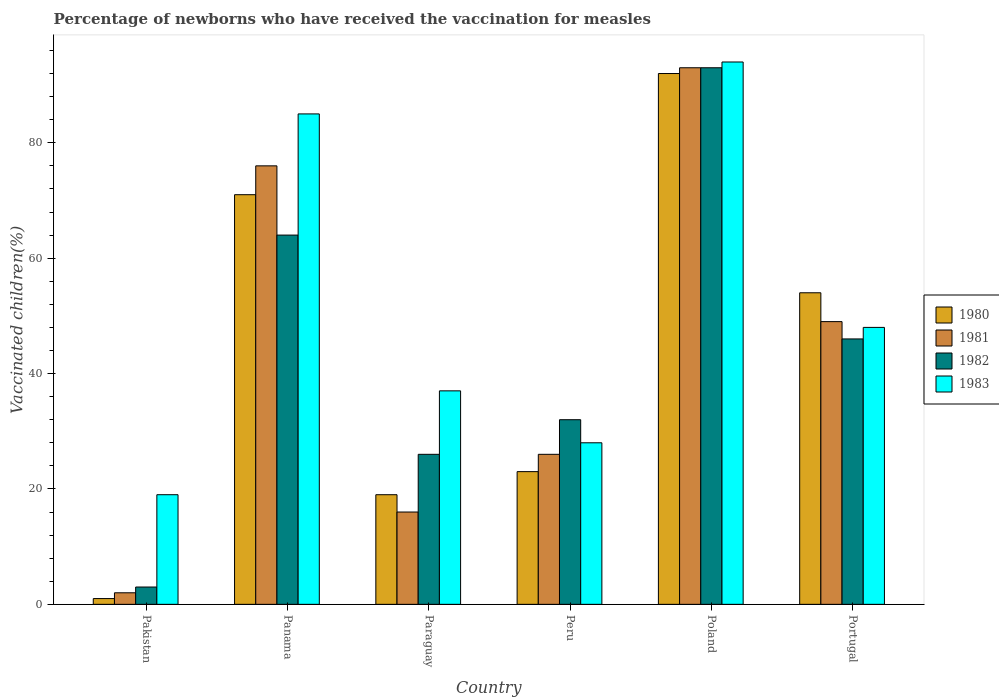How many groups of bars are there?
Your answer should be very brief. 6. How many bars are there on the 3rd tick from the right?
Make the answer very short. 4. In how many cases, is the number of bars for a given country not equal to the number of legend labels?
Offer a very short reply. 0. What is the percentage of vaccinated children in 1981 in Portugal?
Ensure brevity in your answer.  49. Across all countries, what is the maximum percentage of vaccinated children in 1980?
Offer a very short reply. 92. In which country was the percentage of vaccinated children in 1980 minimum?
Your answer should be very brief. Pakistan. What is the total percentage of vaccinated children in 1980 in the graph?
Keep it short and to the point. 260. What is the difference between the percentage of vaccinated children in 1983 in Peru and the percentage of vaccinated children in 1982 in Panama?
Provide a short and direct response. -36. What is the average percentage of vaccinated children in 1981 per country?
Keep it short and to the point. 43.67. What is the difference between the percentage of vaccinated children of/in 1982 and percentage of vaccinated children of/in 1980 in Paraguay?
Your answer should be compact. 7. What is the ratio of the percentage of vaccinated children in 1983 in Peru to that in Portugal?
Give a very brief answer. 0.58. Is the difference between the percentage of vaccinated children in 1982 in Pakistan and Paraguay greater than the difference between the percentage of vaccinated children in 1980 in Pakistan and Paraguay?
Your answer should be compact. No. What is the difference between the highest and the lowest percentage of vaccinated children in 1980?
Keep it short and to the point. 91. Is the sum of the percentage of vaccinated children in 1983 in Pakistan and Portugal greater than the maximum percentage of vaccinated children in 1981 across all countries?
Your response must be concise. No. Is it the case that in every country, the sum of the percentage of vaccinated children in 1981 and percentage of vaccinated children in 1980 is greater than the percentage of vaccinated children in 1982?
Your response must be concise. No. Are all the bars in the graph horizontal?
Offer a very short reply. No. Are the values on the major ticks of Y-axis written in scientific E-notation?
Give a very brief answer. No. Does the graph contain grids?
Provide a succinct answer. No. Where does the legend appear in the graph?
Provide a succinct answer. Center right. How many legend labels are there?
Your response must be concise. 4. What is the title of the graph?
Keep it short and to the point. Percentage of newborns who have received the vaccination for measles. What is the label or title of the X-axis?
Ensure brevity in your answer.  Country. What is the label or title of the Y-axis?
Give a very brief answer. Vaccinated children(%). What is the Vaccinated children(%) in 1980 in Pakistan?
Provide a short and direct response. 1. What is the Vaccinated children(%) of 1981 in Pakistan?
Give a very brief answer. 2. What is the Vaccinated children(%) in 1982 in Pakistan?
Provide a succinct answer. 3. What is the Vaccinated children(%) of 1983 in Pakistan?
Your answer should be compact. 19. What is the Vaccinated children(%) of 1980 in Panama?
Your response must be concise. 71. What is the Vaccinated children(%) of 1981 in Paraguay?
Give a very brief answer. 16. What is the Vaccinated children(%) in 1982 in Paraguay?
Ensure brevity in your answer.  26. What is the Vaccinated children(%) of 1980 in Poland?
Ensure brevity in your answer.  92. What is the Vaccinated children(%) in 1981 in Poland?
Make the answer very short. 93. What is the Vaccinated children(%) in 1982 in Poland?
Offer a terse response. 93. What is the Vaccinated children(%) in 1983 in Poland?
Keep it short and to the point. 94. What is the Vaccinated children(%) of 1982 in Portugal?
Provide a succinct answer. 46. What is the Vaccinated children(%) of 1983 in Portugal?
Provide a succinct answer. 48. Across all countries, what is the maximum Vaccinated children(%) of 1980?
Make the answer very short. 92. Across all countries, what is the maximum Vaccinated children(%) of 1981?
Provide a succinct answer. 93. Across all countries, what is the maximum Vaccinated children(%) in 1982?
Offer a very short reply. 93. Across all countries, what is the maximum Vaccinated children(%) in 1983?
Make the answer very short. 94. Across all countries, what is the minimum Vaccinated children(%) of 1980?
Your answer should be very brief. 1. Across all countries, what is the minimum Vaccinated children(%) in 1981?
Provide a succinct answer. 2. Across all countries, what is the minimum Vaccinated children(%) in 1982?
Offer a very short reply. 3. What is the total Vaccinated children(%) of 1980 in the graph?
Your response must be concise. 260. What is the total Vaccinated children(%) in 1981 in the graph?
Provide a succinct answer. 262. What is the total Vaccinated children(%) of 1982 in the graph?
Your answer should be very brief. 264. What is the total Vaccinated children(%) in 1983 in the graph?
Ensure brevity in your answer.  311. What is the difference between the Vaccinated children(%) of 1980 in Pakistan and that in Panama?
Give a very brief answer. -70. What is the difference between the Vaccinated children(%) in 1981 in Pakistan and that in Panama?
Your answer should be compact. -74. What is the difference between the Vaccinated children(%) of 1982 in Pakistan and that in Panama?
Your response must be concise. -61. What is the difference between the Vaccinated children(%) in 1983 in Pakistan and that in Panama?
Your response must be concise. -66. What is the difference between the Vaccinated children(%) of 1980 in Pakistan and that in Paraguay?
Provide a short and direct response. -18. What is the difference between the Vaccinated children(%) of 1983 in Pakistan and that in Paraguay?
Provide a short and direct response. -18. What is the difference between the Vaccinated children(%) in 1981 in Pakistan and that in Peru?
Offer a very short reply. -24. What is the difference between the Vaccinated children(%) of 1983 in Pakistan and that in Peru?
Give a very brief answer. -9. What is the difference between the Vaccinated children(%) of 1980 in Pakistan and that in Poland?
Offer a very short reply. -91. What is the difference between the Vaccinated children(%) of 1981 in Pakistan and that in Poland?
Ensure brevity in your answer.  -91. What is the difference between the Vaccinated children(%) of 1982 in Pakistan and that in Poland?
Your response must be concise. -90. What is the difference between the Vaccinated children(%) in 1983 in Pakistan and that in Poland?
Your answer should be compact. -75. What is the difference between the Vaccinated children(%) in 1980 in Pakistan and that in Portugal?
Provide a succinct answer. -53. What is the difference between the Vaccinated children(%) of 1981 in Pakistan and that in Portugal?
Provide a short and direct response. -47. What is the difference between the Vaccinated children(%) of 1982 in Pakistan and that in Portugal?
Ensure brevity in your answer.  -43. What is the difference between the Vaccinated children(%) of 1983 in Pakistan and that in Portugal?
Your answer should be compact. -29. What is the difference between the Vaccinated children(%) of 1980 in Panama and that in Paraguay?
Your answer should be compact. 52. What is the difference between the Vaccinated children(%) in 1980 in Panama and that in Peru?
Offer a terse response. 48. What is the difference between the Vaccinated children(%) of 1980 in Panama and that in Poland?
Your answer should be compact. -21. What is the difference between the Vaccinated children(%) of 1982 in Panama and that in Poland?
Your response must be concise. -29. What is the difference between the Vaccinated children(%) in 1983 in Panama and that in Poland?
Provide a short and direct response. -9. What is the difference between the Vaccinated children(%) of 1980 in Panama and that in Portugal?
Offer a very short reply. 17. What is the difference between the Vaccinated children(%) of 1982 in Panama and that in Portugal?
Provide a succinct answer. 18. What is the difference between the Vaccinated children(%) in 1983 in Panama and that in Portugal?
Offer a very short reply. 37. What is the difference between the Vaccinated children(%) of 1982 in Paraguay and that in Peru?
Provide a short and direct response. -6. What is the difference between the Vaccinated children(%) in 1983 in Paraguay and that in Peru?
Provide a short and direct response. 9. What is the difference between the Vaccinated children(%) in 1980 in Paraguay and that in Poland?
Your answer should be very brief. -73. What is the difference between the Vaccinated children(%) of 1981 in Paraguay and that in Poland?
Your response must be concise. -77. What is the difference between the Vaccinated children(%) in 1982 in Paraguay and that in Poland?
Ensure brevity in your answer.  -67. What is the difference between the Vaccinated children(%) in 1983 in Paraguay and that in Poland?
Your response must be concise. -57. What is the difference between the Vaccinated children(%) of 1980 in Paraguay and that in Portugal?
Provide a succinct answer. -35. What is the difference between the Vaccinated children(%) of 1981 in Paraguay and that in Portugal?
Your answer should be very brief. -33. What is the difference between the Vaccinated children(%) in 1982 in Paraguay and that in Portugal?
Your answer should be compact. -20. What is the difference between the Vaccinated children(%) of 1980 in Peru and that in Poland?
Give a very brief answer. -69. What is the difference between the Vaccinated children(%) of 1981 in Peru and that in Poland?
Provide a succinct answer. -67. What is the difference between the Vaccinated children(%) of 1982 in Peru and that in Poland?
Your response must be concise. -61. What is the difference between the Vaccinated children(%) in 1983 in Peru and that in Poland?
Your answer should be very brief. -66. What is the difference between the Vaccinated children(%) of 1980 in Peru and that in Portugal?
Offer a terse response. -31. What is the difference between the Vaccinated children(%) in 1983 in Peru and that in Portugal?
Ensure brevity in your answer.  -20. What is the difference between the Vaccinated children(%) in 1980 in Poland and that in Portugal?
Provide a succinct answer. 38. What is the difference between the Vaccinated children(%) of 1982 in Poland and that in Portugal?
Your response must be concise. 47. What is the difference between the Vaccinated children(%) in 1983 in Poland and that in Portugal?
Give a very brief answer. 46. What is the difference between the Vaccinated children(%) in 1980 in Pakistan and the Vaccinated children(%) in 1981 in Panama?
Make the answer very short. -75. What is the difference between the Vaccinated children(%) of 1980 in Pakistan and the Vaccinated children(%) of 1982 in Panama?
Provide a short and direct response. -63. What is the difference between the Vaccinated children(%) of 1980 in Pakistan and the Vaccinated children(%) of 1983 in Panama?
Provide a succinct answer. -84. What is the difference between the Vaccinated children(%) of 1981 in Pakistan and the Vaccinated children(%) of 1982 in Panama?
Give a very brief answer. -62. What is the difference between the Vaccinated children(%) in 1981 in Pakistan and the Vaccinated children(%) in 1983 in Panama?
Your answer should be compact. -83. What is the difference between the Vaccinated children(%) of 1982 in Pakistan and the Vaccinated children(%) of 1983 in Panama?
Your response must be concise. -82. What is the difference between the Vaccinated children(%) of 1980 in Pakistan and the Vaccinated children(%) of 1981 in Paraguay?
Offer a terse response. -15. What is the difference between the Vaccinated children(%) of 1980 in Pakistan and the Vaccinated children(%) of 1982 in Paraguay?
Offer a terse response. -25. What is the difference between the Vaccinated children(%) of 1980 in Pakistan and the Vaccinated children(%) of 1983 in Paraguay?
Keep it short and to the point. -36. What is the difference between the Vaccinated children(%) in 1981 in Pakistan and the Vaccinated children(%) in 1983 in Paraguay?
Provide a short and direct response. -35. What is the difference between the Vaccinated children(%) of 1982 in Pakistan and the Vaccinated children(%) of 1983 in Paraguay?
Ensure brevity in your answer.  -34. What is the difference between the Vaccinated children(%) in 1980 in Pakistan and the Vaccinated children(%) in 1981 in Peru?
Keep it short and to the point. -25. What is the difference between the Vaccinated children(%) of 1980 in Pakistan and the Vaccinated children(%) of 1982 in Peru?
Ensure brevity in your answer.  -31. What is the difference between the Vaccinated children(%) in 1981 in Pakistan and the Vaccinated children(%) in 1983 in Peru?
Offer a terse response. -26. What is the difference between the Vaccinated children(%) of 1982 in Pakistan and the Vaccinated children(%) of 1983 in Peru?
Make the answer very short. -25. What is the difference between the Vaccinated children(%) of 1980 in Pakistan and the Vaccinated children(%) of 1981 in Poland?
Give a very brief answer. -92. What is the difference between the Vaccinated children(%) of 1980 in Pakistan and the Vaccinated children(%) of 1982 in Poland?
Provide a short and direct response. -92. What is the difference between the Vaccinated children(%) in 1980 in Pakistan and the Vaccinated children(%) in 1983 in Poland?
Your response must be concise. -93. What is the difference between the Vaccinated children(%) in 1981 in Pakistan and the Vaccinated children(%) in 1982 in Poland?
Your answer should be very brief. -91. What is the difference between the Vaccinated children(%) of 1981 in Pakistan and the Vaccinated children(%) of 1983 in Poland?
Give a very brief answer. -92. What is the difference between the Vaccinated children(%) of 1982 in Pakistan and the Vaccinated children(%) of 1983 in Poland?
Offer a very short reply. -91. What is the difference between the Vaccinated children(%) in 1980 in Pakistan and the Vaccinated children(%) in 1981 in Portugal?
Provide a succinct answer. -48. What is the difference between the Vaccinated children(%) of 1980 in Pakistan and the Vaccinated children(%) of 1982 in Portugal?
Provide a short and direct response. -45. What is the difference between the Vaccinated children(%) in 1980 in Pakistan and the Vaccinated children(%) in 1983 in Portugal?
Ensure brevity in your answer.  -47. What is the difference between the Vaccinated children(%) of 1981 in Pakistan and the Vaccinated children(%) of 1982 in Portugal?
Offer a terse response. -44. What is the difference between the Vaccinated children(%) in 1981 in Pakistan and the Vaccinated children(%) in 1983 in Portugal?
Offer a terse response. -46. What is the difference between the Vaccinated children(%) in 1982 in Pakistan and the Vaccinated children(%) in 1983 in Portugal?
Keep it short and to the point. -45. What is the difference between the Vaccinated children(%) in 1980 in Panama and the Vaccinated children(%) in 1982 in Paraguay?
Your response must be concise. 45. What is the difference between the Vaccinated children(%) in 1980 in Panama and the Vaccinated children(%) in 1983 in Paraguay?
Ensure brevity in your answer.  34. What is the difference between the Vaccinated children(%) in 1982 in Panama and the Vaccinated children(%) in 1983 in Paraguay?
Your answer should be compact. 27. What is the difference between the Vaccinated children(%) in 1980 in Panama and the Vaccinated children(%) in 1981 in Peru?
Offer a very short reply. 45. What is the difference between the Vaccinated children(%) in 1980 in Panama and the Vaccinated children(%) in 1982 in Peru?
Provide a short and direct response. 39. What is the difference between the Vaccinated children(%) in 1981 in Panama and the Vaccinated children(%) in 1983 in Peru?
Your answer should be very brief. 48. What is the difference between the Vaccinated children(%) of 1980 in Panama and the Vaccinated children(%) of 1981 in Poland?
Offer a terse response. -22. What is the difference between the Vaccinated children(%) of 1980 in Panama and the Vaccinated children(%) of 1983 in Poland?
Make the answer very short. -23. What is the difference between the Vaccinated children(%) in 1981 in Panama and the Vaccinated children(%) in 1982 in Poland?
Ensure brevity in your answer.  -17. What is the difference between the Vaccinated children(%) in 1982 in Panama and the Vaccinated children(%) in 1983 in Poland?
Keep it short and to the point. -30. What is the difference between the Vaccinated children(%) in 1980 in Panama and the Vaccinated children(%) in 1981 in Portugal?
Ensure brevity in your answer.  22. What is the difference between the Vaccinated children(%) in 1980 in Panama and the Vaccinated children(%) in 1983 in Portugal?
Ensure brevity in your answer.  23. What is the difference between the Vaccinated children(%) in 1981 in Panama and the Vaccinated children(%) in 1982 in Portugal?
Provide a short and direct response. 30. What is the difference between the Vaccinated children(%) of 1982 in Panama and the Vaccinated children(%) of 1983 in Portugal?
Offer a terse response. 16. What is the difference between the Vaccinated children(%) of 1980 in Paraguay and the Vaccinated children(%) of 1983 in Peru?
Provide a succinct answer. -9. What is the difference between the Vaccinated children(%) of 1981 in Paraguay and the Vaccinated children(%) of 1983 in Peru?
Your response must be concise. -12. What is the difference between the Vaccinated children(%) of 1982 in Paraguay and the Vaccinated children(%) of 1983 in Peru?
Offer a very short reply. -2. What is the difference between the Vaccinated children(%) in 1980 in Paraguay and the Vaccinated children(%) in 1981 in Poland?
Give a very brief answer. -74. What is the difference between the Vaccinated children(%) of 1980 in Paraguay and the Vaccinated children(%) of 1982 in Poland?
Provide a short and direct response. -74. What is the difference between the Vaccinated children(%) of 1980 in Paraguay and the Vaccinated children(%) of 1983 in Poland?
Ensure brevity in your answer.  -75. What is the difference between the Vaccinated children(%) in 1981 in Paraguay and the Vaccinated children(%) in 1982 in Poland?
Make the answer very short. -77. What is the difference between the Vaccinated children(%) of 1981 in Paraguay and the Vaccinated children(%) of 1983 in Poland?
Make the answer very short. -78. What is the difference between the Vaccinated children(%) in 1982 in Paraguay and the Vaccinated children(%) in 1983 in Poland?
Give a very brief answer. -68. What is the difference between the Vaccinated children(%) in 1980 in Paraguay and the Vaccinated children(%) in 1981 in Portugal?
Keep it short and to the point. -30. What is the difference between the Vaccinated children(%) of 1980 in Paraguay and the Vaccinated children(%) of 1982 in Portugal?
Keep it short and to the point. -27. What is the difference between the Vaccinated children(%) of 1980 in Paraguay and the Vaccinated children(%) of 1983 in Portugal?
Your response must be concise. -29. What is the difference between the Vaccinated children(%) in 1981 in Paraguay and the Vaccinated children(%) in 1983 in Portugal?
Keep it short and to the point. -32. What is the difference between the Vaccinated children(%) of 1982 in Paraguay and the Vaccinated children(%) of 1983 in Portugal?
Your response must be concise. -22. What is the difference between the Vaccinated children(%) in 1980 in Peru and the Vaccinated children(%) in 1981 in Poland?
Make the answer very short. -70. What is the difference between the Vaccinated children(%) of 1980 in Peru and the Vaccinated children(%) of 1982 in Poland?
Your answer should be very brief. -70. What is the difference between the Vaccinated children(%) of 1980 in Peru and the Vaccinated children(%) of 1983 in Poland?
Give a very brief answer. -71. What is the difference between the Vaccinated children(%) of 1981 in Peru and the Vaccinated children(%) of 1982 in Poland?
Provide a short and direct response. -67. What is the difference between the Vaccinated children(%) of 1981 in Peru and the Vaccinated children(%) of 1983 in Poland?
Provide a succinct answer. -68. What is the difference between the Vaccinated children(%) in 1982 in Peru and the Vaccinated children(%) in 1983 in Poland?
Offer a very short reply. -62. What is the difference between the Vaccinated children(%) in 1980 in Peru and the Vaccinated children(%) in 1981 in Portugal?
Make the answer very short. -26. What is the difference between the Vaccinated children(%) in 1981 in Peru and the Vaccinated children(%) in 1982 in Portugal?
Offer a very short reply. -20. What is the difference between the Vaccinated children(%) of 1981 in Peru and the Vaccinated children(%) of 1983 in Portugal?
Your answer should be very brief. -22. What is the difference between the Vaccinated children(%) of 1980 in Poland and the Vaccinated children(%) of 1982 in Portugal?
Ensure brevity in your answer.  46. What is the difference between the Vaccinated children(%) of 1980 in Poland and the Vaccinated children(%) of 1983 in Portugal?
Your answer should be very brief. 44. What is the average Vaccinated children(%) of 1980 per country?
Make the answer very short. 43.33. What is the average Vaccinated children(%) in 1981 per country?
Provide a short and direct response. 43.67. What is the average Vaccinated children(%) in 1983 per country?
Offer a terse response. 51.83. What is the difference between the Vaccinated children(%) of 1980 and Vaccinated children(%) of 1983 in Pakistan?
Keep it short and to the point. -18. What is the difference between the Vaccinated children(%) in 1981 and Vaccinated children(%) in 1983 in Pakistan?
Make the answer very short. -17. What is the difference between the Vaccinated children(%) in 1982 and Vaccinated children(%) in 1983 in Pakistan?
Provide a short and direct response. -16. What is the difference between the Vaccinated children(%) in 1980 and Vaccinated children(%) in 1981 in Panama?
Provide a short and direct response. -5. What is the difference between the Vaccinated children(%) in 1980 and Vaccinated children(%) in 1982 in Panama?
Provide a short and direct response. 7. What is the difference between the Vaccinated children(%) of 1980 and Vaccinated children(%) of 1983 in Panama?
Provide a succinct answer. -14. What is the difference between the Vaccinated children(%) of 1981 and Vaccinated children(%) of 1982 in Panama?
Ensure brevity in your answer.  12. What is the difference between the Vaccinated children(%) of 1981 and Vaccinated children(%) of 1983 in Panama?
Offer a terse response. -9. What is the difference between the Vaccinated children(%) in 1980 and Vaccinated children(%) in 1981 in Paraguay?
Offer a terse response. 3. What is the difference between the Vaccinated children(%) in 1982 and Vaccinated children(%) in 1983 in Paraguay?
Ensure brevity in your answer.  -11. What is the difference between the Vaccinated children(%) in 1980 and Vaccinated children(%) in 1981 in Peru?
Ensure brevity in your answer.  -3. What is the difference between the Vaccinated children(%) of 1980 and Vaccinated children(%) of 1982 in Peru?
Offer a terse response. -9. What is the difference between the Vaccinated children(%) in 1981 and Vaccinated children(%) in 1982 in Peru?
Offer a terse response. -6. What is the difference between the Vaccinated children(%) of 1981 and Vaccinated children(%) of 1983 in Peru?
Make the answer very short. -2. What is the difference between the Vaccinated children(%) in 1982 and Vaccinated children(%) in 1983 in Peru?
Offer a very short reply. 4. What is the difference between the Vaccinated children(%) of 1981 and Vaccinated children(%) of 1982 in Poland?
Keep it short and to the point. 0. What is the difference between the Vaccinated children(%) in 1981 and Vaccinated children(%) in 1983 in Poland?
Your response must be concise. -1. What is the difference between the Vaccinated children(%) of 1982 and Vaccinated children(%) of 1983 in Poland?
Provide a succinct answer. -1. What is the difference between the Vaccinated children(%) in 1980 and Vaccinated children(%) in 1981 in Portugal?
Your answer should be compact. 5. What is the difference between the Vaccinated children(%) in 1980 and Vaccinated children(%) in 1983 in Portugal?
Give a very brief answer. 6. What is the difference between the Vaccinated children(%) of 1981 and Vaccinated children(%) of 1982 in Portugal?
Give a very brief answer. 3. What is the difference between the Vaccinated children(%) of 1981 and Vaccinated children(%) of 1983 in Portugal?
Provide a short and direct response. 1. What is the ratio of the Vaccinated children(%) of 1980 in Pakistan to that in Panama?
Ensure brevity in your answer.  0.01. What is the ratio of the Vaccinated children(%) in 1981 in Pakistan to that in Panama?
Offer a terse response. 0.03. What is the ratio of the Vaccinated children(%) in 1982 in Pakistan to that in Panama?
Provide a short and direct response. 0.05. What is the ratio of the Vaccinated children(%) in 1983 in Pakistan to that in Panama?
Your answer should be compact. 0.22. What is the ratio of the Vaccinated children(%) of 1980 in Pakistan to that in Paraguay?
Your answer should be compact. 0.05. What is the ratio of the Vaccinated children(%) in 1981 in Pakistan to that in Paraguay?
Make the answer very short. 0.12. What is the ratio of the Vaccinated children(%) of 1982 in Pakistan to that in Paraguay?
Provide a short and direct response. 0.12. What is the ratio of the Vaccinated children(%) in 1983 in Pakistan to that in Paraguay?
Provide a succinct answer. 0.51. What is the ratio of the Vaccinated children(%) of 1980 in Pakistan to that in Peru?
Offer a very short reply. 0.04. What is the ratio of the Vaccinated children(%) in 1981 in Pakistan to that in Peru?
Offer a terse response. 0.08. What is the ratio of the Vaccinated children(%) in 1982 in Pakistan to that in Peru?
Provide a short and direct response. 0.09. What is the ratio of the Vaccinated children(%) of 1983 in Pakistan to that in Peru?
Provide a short and direct response. 0.68. What is the ratio of the Vaccinated children(%) in 1980 in Pakistan to that in Poland?
Your answer should be compact. 0.01. What is the ratio of the Vaccinated children(%) of 1981 in Pakistan to that in Poland?
Provide a short and direct response. 0.02. What is the ratio of the Vaccinated children(%) in 1982 in Pakistan to that in Poland?
Offer a terse response. 0.03. What is the ratio of the Vaccinated children(%) in 1983 in Pakistan to that in Poland?
Your response must be concise. 0.2. What is the ratio of the Vaccinated children(%) in 1980 in Pakistan to that in Portugal?
Offer a very short reply. 0.02. What is the ratio of the Vaccinated children(%) of 1981 in Pakistan to that in Portugal?
Make the answer very short. 0.04. What is the ratio of the Vaccinated children(%) of 1982 in Pakistan to that in Portugal?
Your answer should be compact. 0.07. What is the ratio of the Vaccinated children(%) in 1983 in Pakistan to that in Portugal?
Ensure brevity in your answer.  0.4. What is the ratio of the Vaccinated children(%) in 1980 in Panama to that in Paraguay?
Offer a terse response. 3.74. What is the ratio of the Vaccinated children(%) of 1981 in Panama to that in Paraguay?
Your answer should be very brief. 4.75. What is the ratio of the Vaccinated children(%) in 1982 in Panama to that in Paraguay?
Your answer should be compact. 2.46. What is the ratio of the Vaccinated children(%) of 1983 in Panama to that in Paraguay?
Ensure brevity in your answer.  2.3. What is the ratio of the Vaccinated children(%) of 1980 in Panama to that in Peru?
Keep it short and to the point. 3.09. What is the ratio of the Vaccinated children(%) in 1981 in Panama to that in Peru?
Your answer should be very brief. 2.92. What is the ratio of the Vaccinated children(%) of 1982 in Panama to that in Peru?
Ensure brevity in your answer.  2. What is the ratio of the Vaccinated children(%) in 1983 in Panama to that in Peru?
Make the answer very short. 3.04. What is the ratio of the Vaccinated children(%) of 1980 in Panama to that in Poland?
Your response must be concise. 0.77. What is the ratio of the Vaccinated children(%) in 1981 in Panama to that in Poland?
Make the answer very short. 0.82. What is the ratio of the Vaccinated children(%) of 1982 in Panama to that in Poland?
Ensure brevity in your answer.  0.69. What is the ratio of the Vaccinated children(%) in 1983 in Panama to that in Poland?
Ensure brevity in your answer.  0.9. What is the ratio of the Vaccinated children(%) of 1980 in Panama to that in Portugal?
Offer a very short reply. 1.31. What is the ratio of the Vaccinated children(%) in 1981 in Panama to that in Portugal?
Your answer should be very brief. 1.55. What is the ratio of the Vaccinated children(%) of 1982 in Panama to that in Portugal?
Offer a terse response. 1.39. What is the ratio of the Vaccinated children(%) of 1983 in Panama to that in Portugal?
Keep it short and to the point. 1.77. What is the ratio of the Vaccinated children(%) in 1980 in Paraguay to that in Peru?
Ensure brevity in your answer.  0.83. What is the ratio of the Vaccinated children(%) of 1981 in Paraguay to that in Peru?
Your answer should be very brief. 0.62. What is the ratio of the Vaccinated children(%) of 1982 in Paraguay to that in Peru?
Make the answer very short. 0.81. What is the ratio of the Vaccinated children(%) of 1983 in Paraguay to that in Peru?
Make the answer very short. 1.32. What is the ratio of the Vaccinated children(%) of 1980 in Paraguay to that in Poland?
Keep it short and to the point. 0.21. What is the ratio of the Vaccinated children(%) of 1981 in Paraguay to that in Poland?
Ensure brevity in your answer.  0.17. What is the ratio of the Vaccinated children(%) in 1982 in Paraguay to that in Poland?
Your answer should be very brief. 0.28. What is the ratio of the Vaccinated children(%) of 1983 in Paraguay to that in Poland?
Your answer should be very brief. 0.39. What is the ratio of the Vaccinated children(%) of 1980 in Paraguay to that in Portugal?
Offer a very short reply. 0.35. What is the ratio of the Vaccinated children(%) of 1981 in Paraguay to that in Portugal?
Make the answer very short. 0.33. What is the ratio of the Vaccinated children(%) in 1982 in Paraguay to that in Portugal?
Offer a terse response. 0.57. What is the ratio of the Vaccinated children(%) of 1983 in Paraguay to that in Portugal?
Your answer should be very brief. 0.77. What is the ratio of the Vaccinated children(%) in 1980 in Peru to that in Poland?
Provide a short and direct response. 0.25. What is the ratio of the Vaccinated children(%) of 1981 in Peru to that in Poland?
Your response must be concise. 0.28. What is the ratio of the Vaccinated children(%) of 1982 in Peru to that in Poland?
Give a very brief answer. 0.34. What is the ratio of the Vaccinated children(%) of 1983 in Peru to that in Poland?
Make the answer very short. 0.3. What is the ratio of the Vaccinated children(%) of 1980 in Peru to that in Portugal?
Offer a very short reply. 0.43. What is the ratio of the Vaccinated children(%) of 1981 in Peru to that in Portugal?
Provide a succinct answer. 0.53. What is the ratio of the Vaccinated children(%) in 1982 in Peru to that in Portugal?
Provide a succinct answer. 0.7. What is the ratio of the Vaccinated children(%) in 1983 in Peru to that in Portugal?
Keep it short and to the point. 0.58. What is the ratio of the Vaccinated children(%) of 1980 in Poland to that in Portugal?
Provide a succinct answer. 1.7. What is the ratio of the Vaccinated children(%) in 1981 in Poland to that in Portugal?
Keep it short and to the point. 1.9. What is the ratio of the Vaccinated children(%) in 1982 in Poland to that in Portugal?
Offer a terse response. 2.02. What is the ratio of the Vaccinated children(%) of 1983 in Poland to that in Portugal?
Your response must be concise. 1.96. What is the difference between the highest and the second highest Vaccinated children(%) in 1980?
Your answer should be compact. 21. What is the difference between the highest and the second highest Vaccinated children(%) of 1981?
Offer a terse response. 17. What is the difference between the highest and the second highest Vaccinated children(%) of 1983?
Ensure brevity in your answer.  9. What is the difference between the highest and the lowest Vaccinated children(%) of 1980?
Your response must be concise. 91. What is the difference between the highest and the lowest Vaccinated children(%) in 1981?
Offer a very short reply. 91. What is the difference between the highest and the lowest Vaccinated children(%) in 1982?
Your answer should be very brief. 90. 